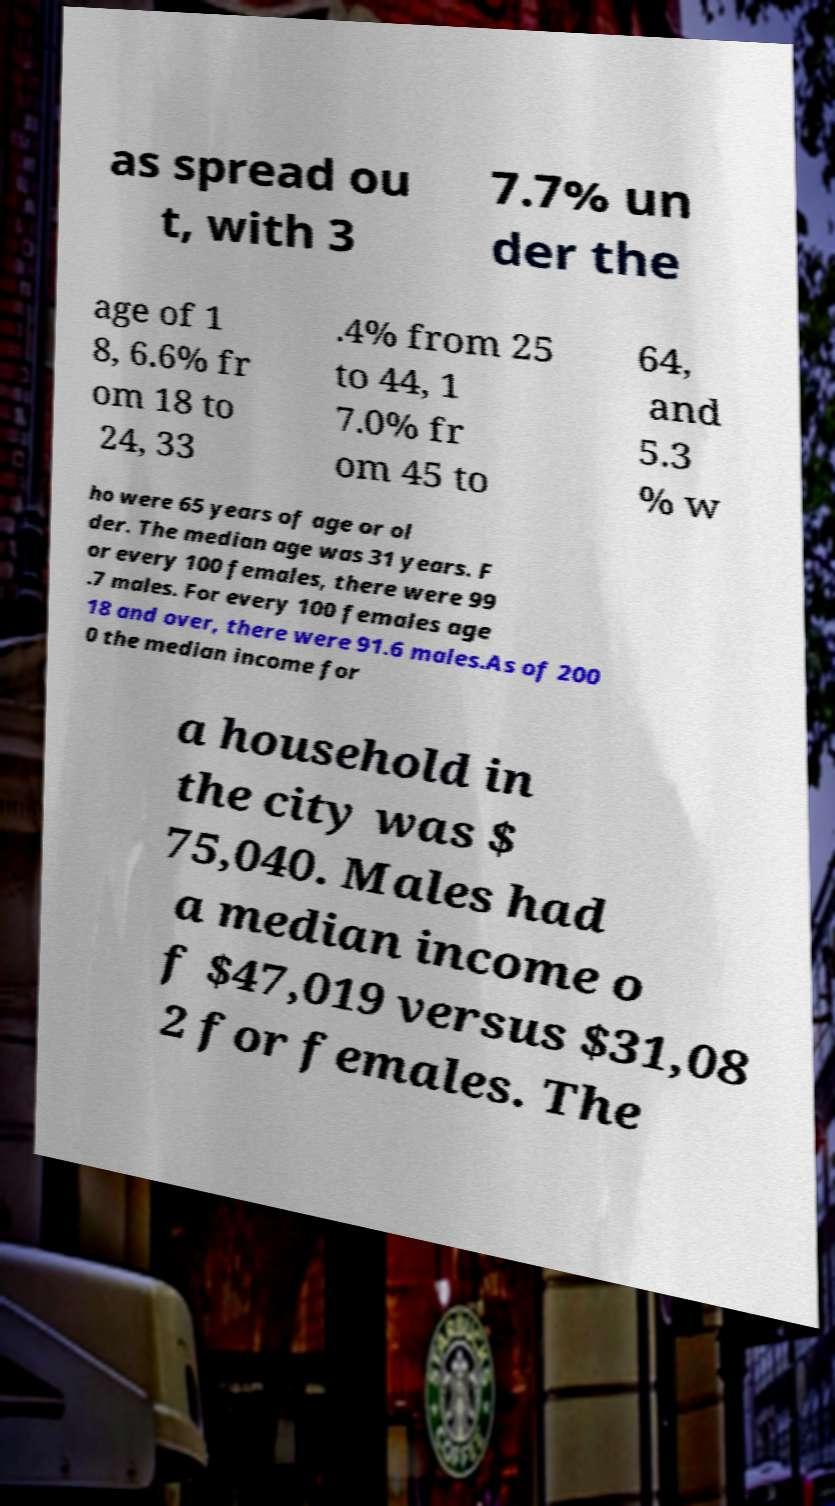For documentation purposes, I need the text within this image transcribed. Could you provide that? as spread ou t, with 3 7.7% un der the age of 1 8, 6.6% fr om 18 to 24, 33 .4% from 25 to 44, 1 7.0% fr om 45 to 64, and 5.3 % w ho were 65 years of age or ol der. The median age was 31 years. F or every 100 females, there were 99 .7 males. For every 100 females age 18 and over, there were 91.6 males.As of 200 0 the median income for a household in the city was $ 75,040. Males had a median income o f $47,019 versus $31,08 2 for females. The 